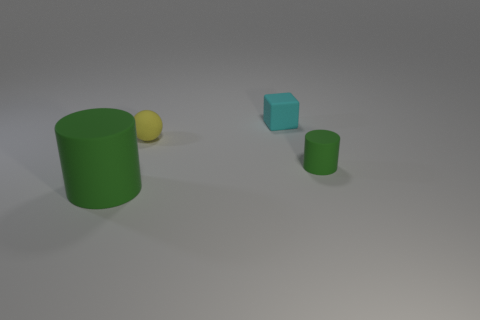The small cyan rubber thing has what shape? The small cyan object appears to be a cube, featuring equal length in width, height, and depth that give it its characteristic six-sided square shape. 